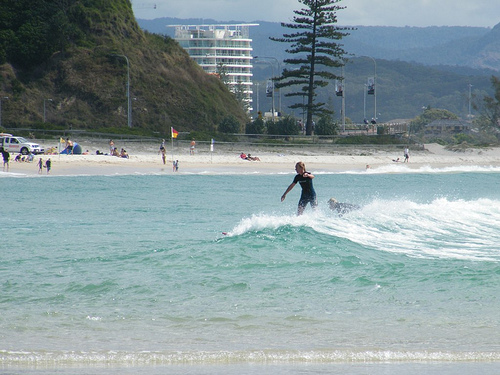Please provide the bounding box coordinate of the region this sentence describes: person in the water. The bounding box coordinates for the person in the water are [0.71, 0.44, 0.76, 0.48]. These coordinates capture the specific area where a person is seen within the water's expanse. 